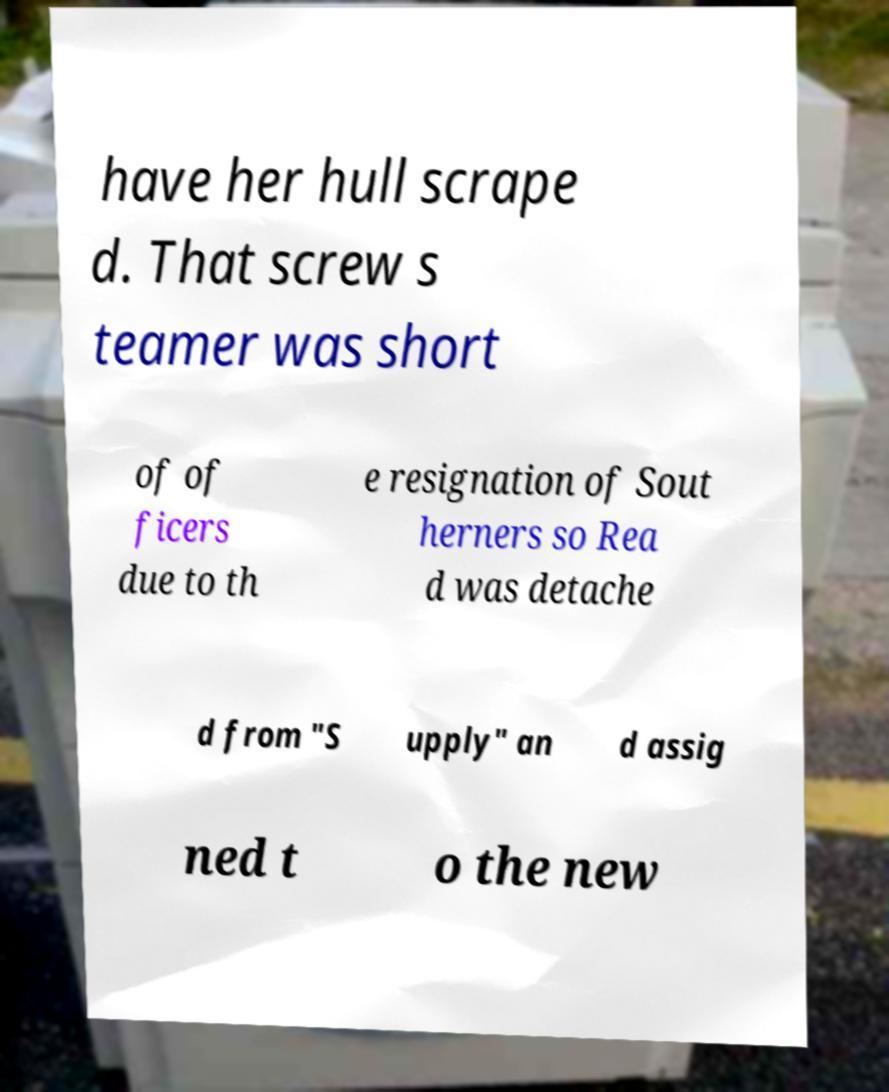Please read and relay the text visible in this image. What does it say? have her hull scrape d. That screw s teamer was short of of ficers due to th e resignation of Sout herners so Rea d was detache d from "S upply" an d assig ned t o the new 